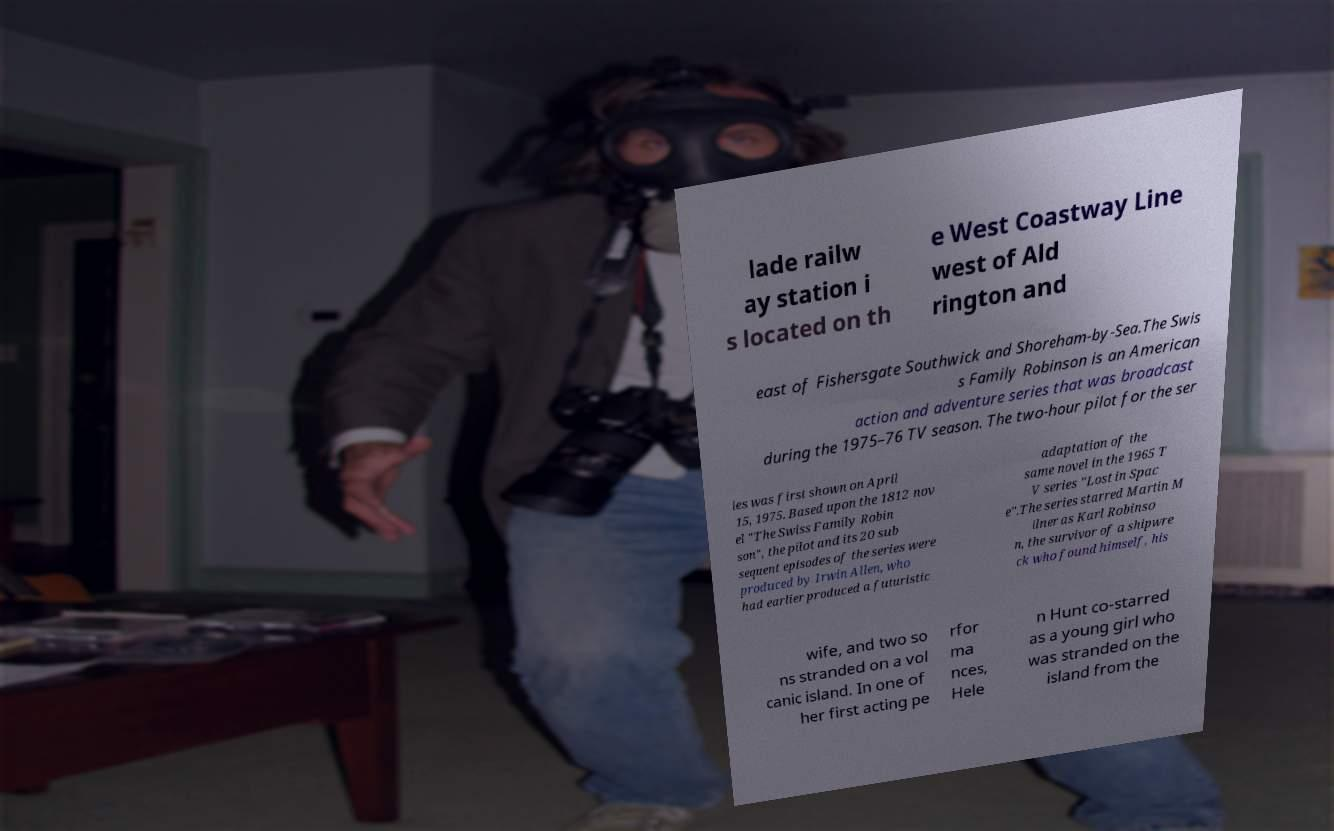Can you accurately transcribe the text from the provided image for me? lade railw ay station i s located on th e West Coastway Line west of Ald rington and east of Fishersgate Southwick and Shoreham-by-Sea.The Swis s Family Robinson is an American action and adventure series that was broadcast during the 1975–76 TV season. The two-hour pilot for the ser ies was first shown on April 15, 1975. Based upon the 1812 nov el "The Swiss Family Robin son", the pilot and its 20 sub sequent episodes of the series were produced by Irwin Allen, who had earlier produced a futuristic adaptation of the same novel in the 1965 T V series "Lost in Spac e".The series starred Martin M ilner as Karl Robinso n, the survivor of a shipwre ck who found himself, his wife, and two so ns stranded on a vol canic island. In one of her first acting pe rfor ma nces, Hele n Hunt co-starred as a young girl who was stranded on the island from the 